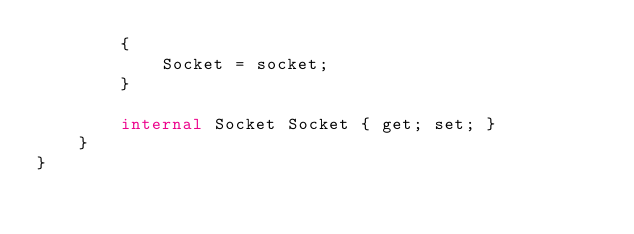<code> <loc_0><loc_0><loc_500><loc_500><_C#_>        {
            Socket = socket;
        }

        internal Socket Socket { get; set; }
    }
}</code> 